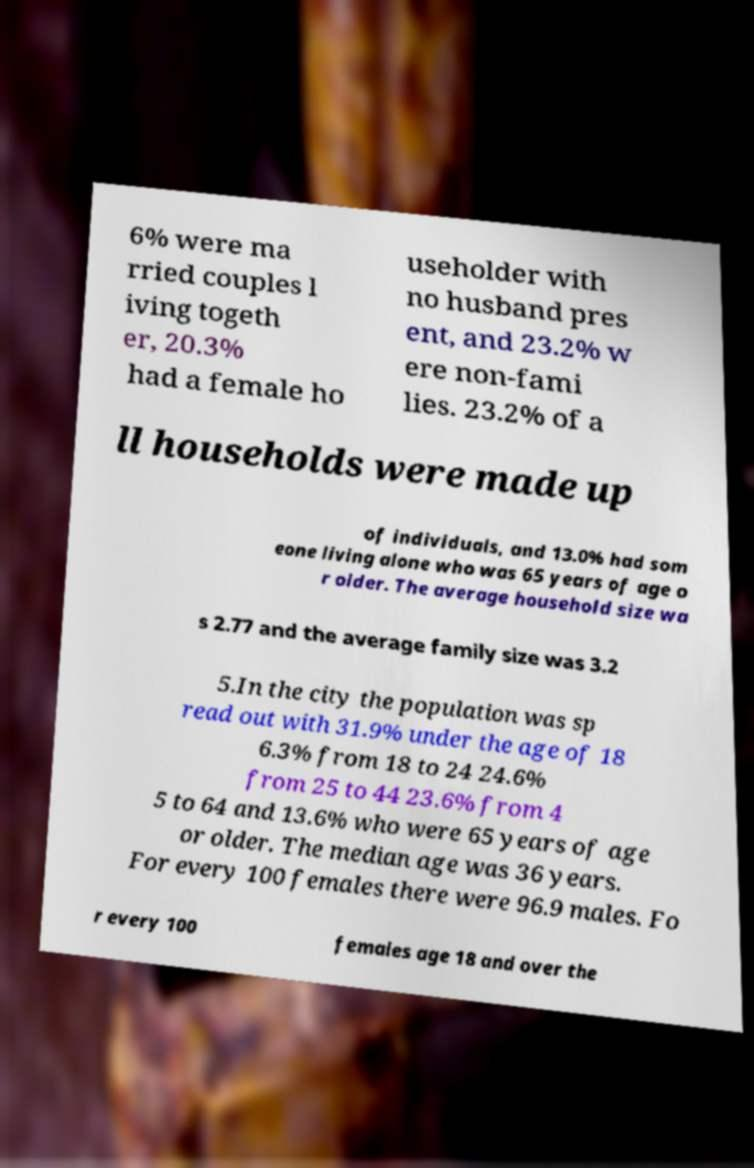Can you read and provide the text displayed in the image?This photo seems to have some interesting text. Can you extract and type it out for me? 6% were ma rried couples l iving togeth er, 20.3% had a female ho useholder with no husband pres ent, and 23.2% w ere non-fami lies. 23.2% of a ll households were made up of individuals, and 13.0% had som eone living alone who was 65 years of age o r older. The average household size wa s 2.77 and the average family size was 3.2 5.In the city the population was sp read out with 31.9% under the age of 18 6.3% from 18 to 24 24.6% from 25 to 44 23.6% from 4 5 to 64 and 13.6% who were 65 years of age or older. The median age was 36 years. For every 100 females there were 96.9 males. Fo r every 100 females age 18 and over the 